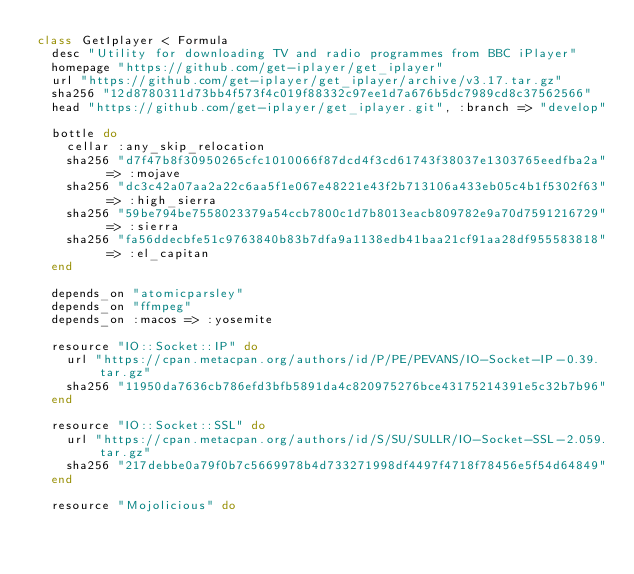<code> <loc_0><loc_0><loc_500><loc_500><_Ruby_>class GetIplayer < Formula
  desc "Utility for downloading TV and radio programmes from BBC iPlayer"
  homepage "https://github.com/get-iplayer/get_iplayer"
  url "https://github.com/get-iplayer/get_iplayer/archive/v3.17.tar.gz"
  sha256 "12d8780311d73bb4f573f4c019f88332c97ee1d7a676b5dc7989cd8c37562566"
  head "https://github.com/get-iplayer/get_iplayer.git", :branch => "develop"

  bottle do
    cellar :any_skip_relocation
    sha256 "d7f47b8f30950265cfc1010066f87dcd4f3cd61743f38037e1303765eedfba2a" => :mojave
    sha256 "dc3c42a07aa2a22c6aa5f1e067e48221e43f2b713106a433eb05c4b1f5302f63" => :high_sierra
    sha256 "59be794be7558023379a54ccb7800c1d7b8013eacb809782e9a70d7591216729" => :sierra
    sha256 "fa56ddecbfe51c9763840b83b7dfa9a1138edb41baa21cf91aa28df955583818" => :el_capitan
  end

  depends_on "atomicparsley"
  depends_on "ffmpeg"
  depends_on :macos => :yosemite

  resource "IO::Socket::IP" do
    url "https://cpan.metacpan.org/authors/id/P/PE/PEVANS/IO-Socket-IP-0.39.tar.gz"
    sha256 "11950da7636cb786efd3bfb5891da4c820975276bce43175214391e5c32b7b96"
  end

  resource "IO::Socket::SSL" do
    url "https://cpan.metacpan.org/authors/id/S/SU/SULLR/IO-Socket-SSL-2.059.tar.gz"
    sha256 "217debbe0a79f0b7c5669978b4d733271998df4497f4718f78456e5f54d64849"
  end

  resource "Mojolicious" do</code> 